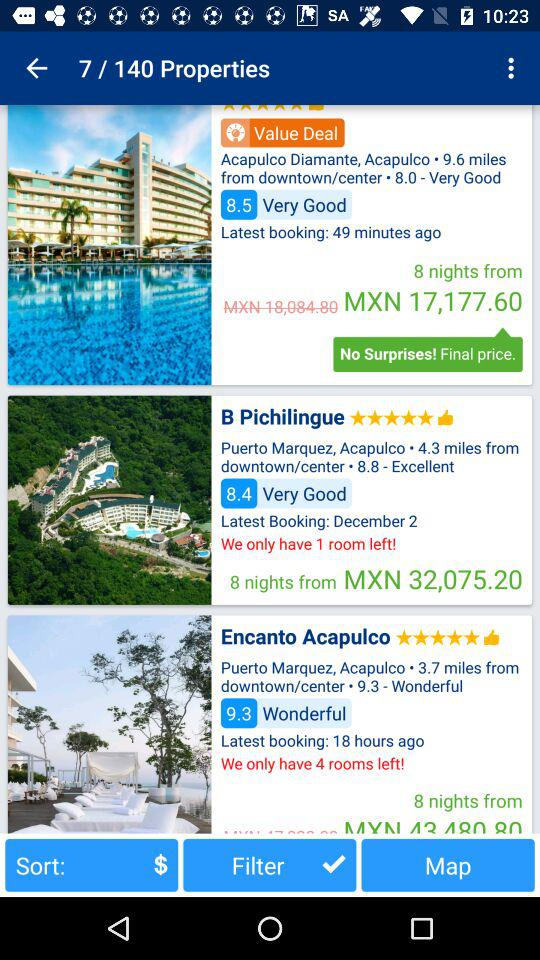When was the latest booking for "Encanto Acapulco" made? The latest booking for "Encanto Acapulco" was made 18 hours ago. 